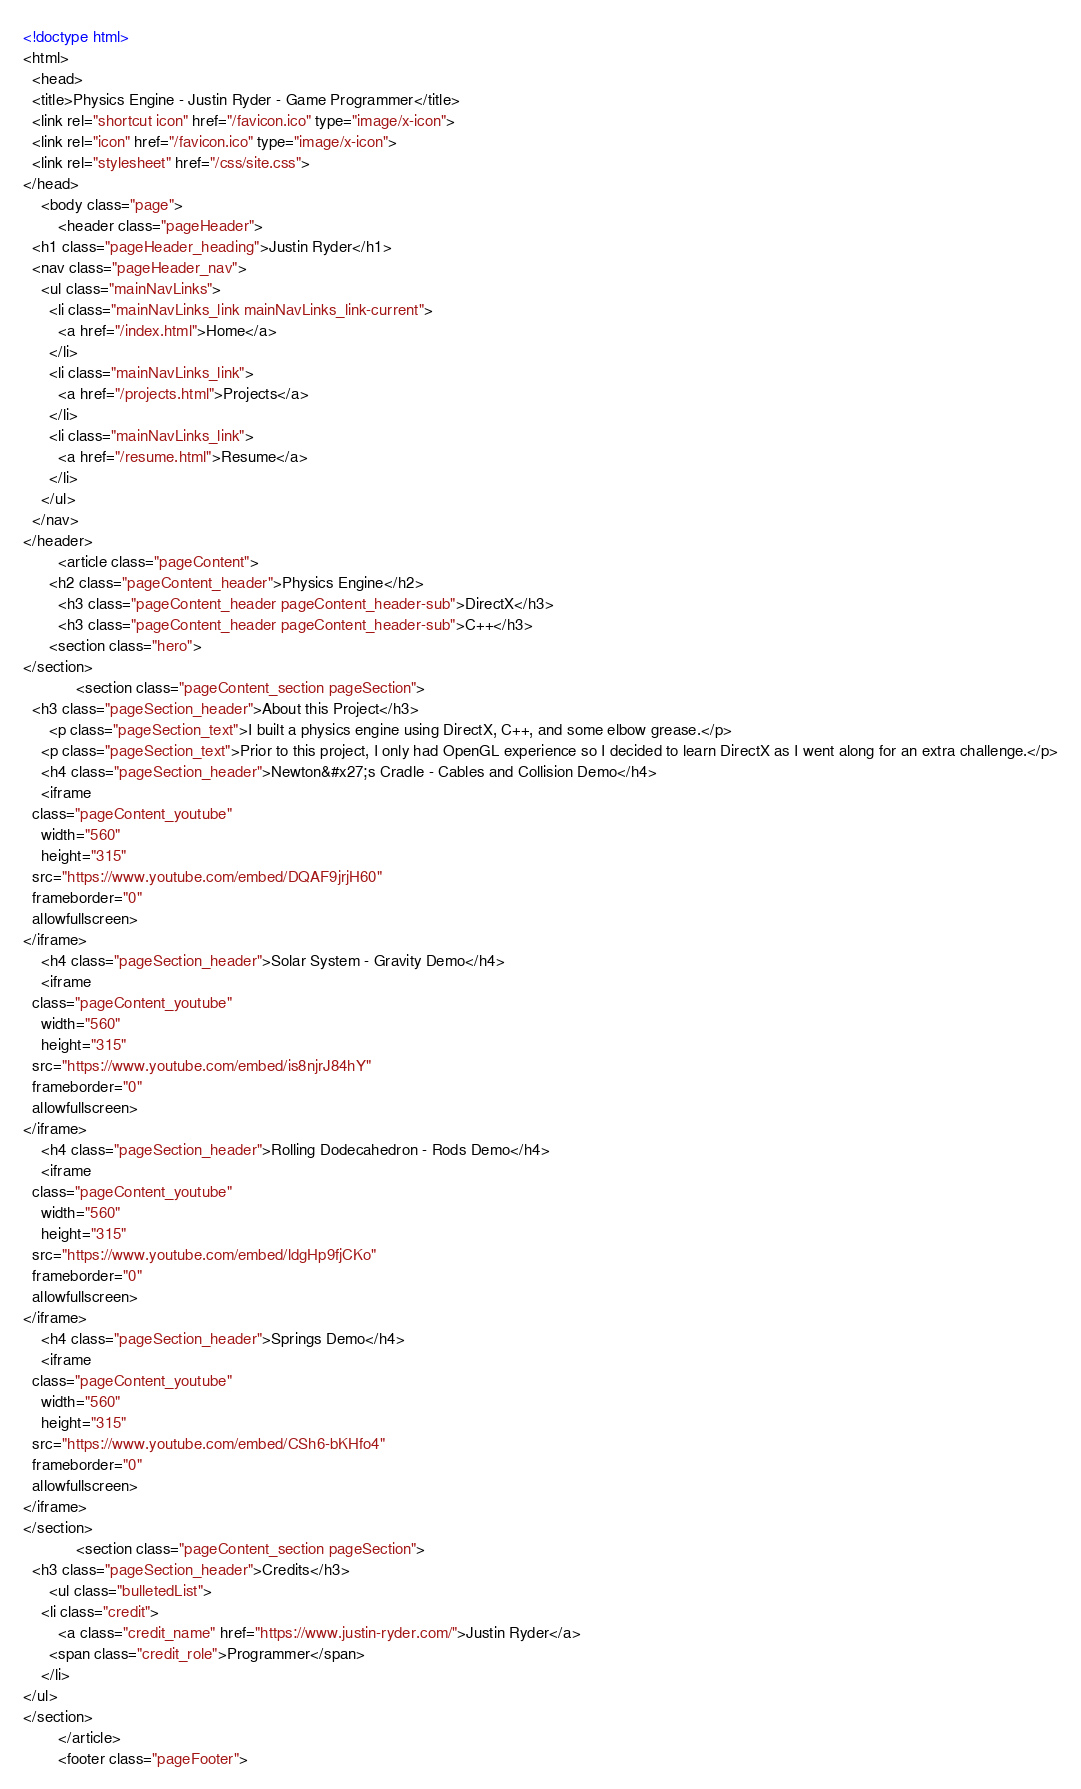<code> <loc_0><loc_0><loc_500><loc_500><_HTML_><!doctype html>
<html>
  <head>
  <title>Physics Engine - Justin Ryder - Game Programmer</title>
  <link rel="shortcut icon" href="/favicon.ico" type="image/x-icon">
  <link rel="icon" href="/favicon.ico" type="image/x-icon">
  <link rel="stylesheet" href="/css/site.css">
</head>
	<body class="page">
		<header class="pageHeader">
  <h1 class="pageHeader_heading">Justin Ryder</h1>
  <nav class="pageHeader_nav">
    <ul class="mainNavLinks">
      <li class="mainNavLinks_link mainNavLinks_link-current">
        <a href="/index.html">Home</a>
      </li>
      <li class="mainNavLinks_link">
        <a href="/projects.html">Projects</a>
      </li>
      <li class="mainNavLinks_link">
        <a href="/resume.html">Resume</a>
      </li>
    </ul>
  </nav>
</header>
		<article class="pageContent">
      <h2 class="pageContent_header">Physics Engine</h2>
        <h3 class="pageContent_header pageContent_header-sub">DirectX</h3>
        <h3 class="pageContent_header pageContent_header-sub">C++</h3>
      <section class="hero">
</section>
  			<section class="pageContent_section pageSection">
  <h3 class="pageSection_header">About this Project</h3>
      <p class="pageSection_text">I built a physics engine using DirectX, C++, and some elbow grease.</p>
    <p class="pageSection_text">Prior to this project, I only had OpenGL experience so I decided to learn DirectX as I went along for an extra challenge.</p>
    <h4 class="pageSection_header">Newton&#x27;s Cradle - Cables and Collision Demo</h4>
    <iframe
  class="pageContent_youtube"
    width="560"
    height="315"
  src="https://www.youtube.com/embed/DQAF9jrjH60"
  frameborder="0"
  allowfullscreen>
</iframe>
    <h4 class="pageSection_header">Solar System - Gravity Demo</h4>
    <iframe
  class="pageContent_youtube"
    width="560"
    height="315"
  src="https://www.youtube.com/embed/is8njrJ84hY"
  frameborder="0"
  allowfullscreen>
</iframe>
    <h4 class="pageSection_header">Rolling Dodecahedron - Rods Demo</h4>
    <iframe
  class="pageContent_youtube"
    width="560"
    height="315"
  src="https://www.youtube.com/embed/ldgHp9fjCKo"
  frameborder="0"
  allowfullscreen>
</iframe>
    <h4 class="pageSection_header">Springs Demo</h4>
    <iframe
  class="pageContent_youtube"
    width="560"
    height="315"
  src="https://www.youtube.com/embed/CSh6-bKHfo4"
  frameborder="0"
  allowfullscreen>
</iframe>
</section>
  			<section class="pageContent_section pageSection">
  <h3 class="pageSection_header">Credits</h3>
      <ul class="bulletedList">
    <li class="credit">
        <a class="credit_name" href="https://www.justin-ryder.com/">Justin Ryder</a>
      <span class="credit_role">Programmer</span>
    </li>
</ul>
</section>
		</article>
		<footer class="pageFooter"></code> 